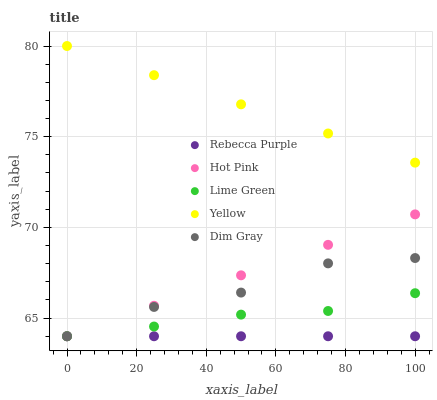Does Rebecca Purple have the minimum area under the curve?
Answer yes or no. Yes. Does Yellow have the maximum area under the curve?
Answer yes or no. Yes. Does Hot Pink have the minimum area under the curve?
Answer yes or no. No. Does Hot Pink have the maximum area under the curve?
Answer yes or no. No. Is Hot Pink the smoothest?
Answer yes or no. Yes. Is Dim Gray the roughest?
Answer yes or no. Yes. Is Lime Green the smoothest?
Answer yes or no. No. Is Lime Green the roughest?
Answer yes or no. No. Does Dim Gray have the lowest value?
Answer yes or no. Yes. Does Yellow have the lowest value?
Answer yes or no. No. Does Yellow have the highest value?
Answer yes or no. Yes. Does Hot Pink have the highest value?
Answer yes or no. No. Is Lime Green less than Yellow?
Answer yes or no. Yes. Is Yellow greater than Hot Pink?
Answer yes or no. Yes. Does Rebecca Purple intersect Dim Gray?
Answer yes or no. Yes. Is Rebecca Purple less than Dim Gray?
Answer yes or no. No. Is Rebecca Purple greater than Dim Gray?
Answer yes or no. No. Does Lime Green intersect Yellow?
Answer yes or no. No. 